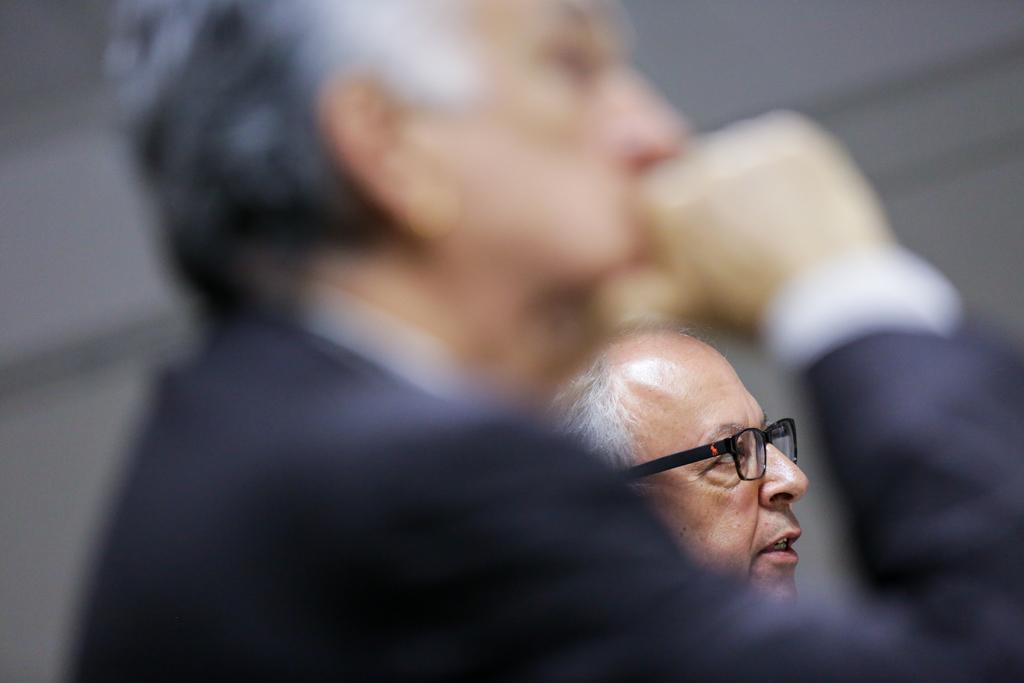In one or two sentences, can you explain what this image depicts? In this image I can see two persons. One person is wearing spectacles. 